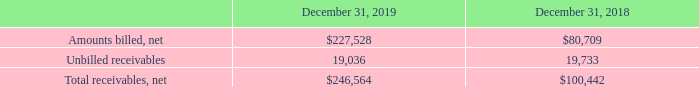ADVANCED ENERGY INDUSTRIES, INC. NOTES TO CONSOLIDATED FINANCIAL STATEMENTS – (continued) (in thousands, except per share amounts)
NOTE 9. ACCOUNTS AND OTHER RECEIVABLE
Accounts and other receivable are recorded at net realizable value. Components of accounts and other receivable, net of reserves, are as follows:
Amounts billed, net consist of amounts that have been invoiced to our customers in accordance with terms and conditions, and are shown net of an allowance for doubtful accounts. These receivables are all short term in nature and do not include any financing components.
Unbilled receivables consist of amounts where we have satisfied our contractual obligations related to inventory stocking contracts with customers. Such amounts are typically invoiced to the customer upon their consumption of the inventory managed under the stocking contracts. We anticipate that substantially all unbilled receivables will be invoiced and collected over the next twelve months. These contracts do not include any financing components.
How were Accounts and other receivable recorded by the company? At net realizable value. What was the amount of unbilled receivables in 2019?
Answer scale should be: thousand. 19,036. What were the net amounts billed in 2018?
Answer scale should be: thousand. $80,709. What was the change in unbilled receivables between 2018 and 2019?
Answer scale should be: thousand. 19,036-19,733
Answer: -697. What was the change in net amounts billed between 2018 and 2019?
Answer scale should be: thousand. $227,528-$80,709
Answer: 146819. What was the percentage change in net total receivables between 2018 and 2019?
Answer scale should be: percent. ($246,564-$100,442)/$100,442
Answer: 145.48. 